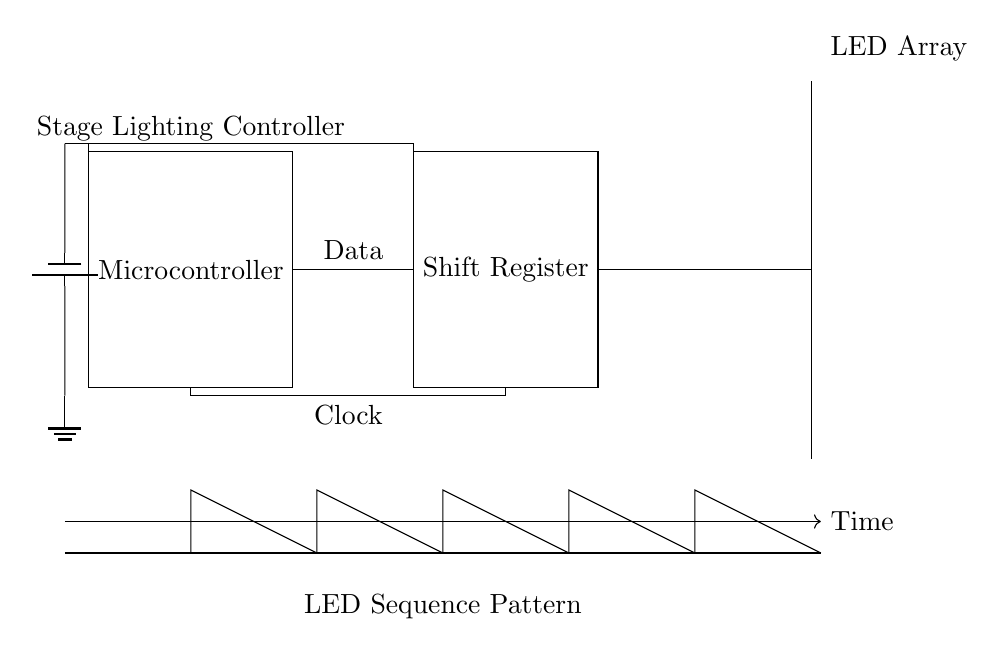What is the main component controlling the LED sequencing? The main component is the Microcontroller, as it interfaces with the shift register to send data and control the LED pattern.
Answer: Microcontroller How many LEDs are present in the circuit? The circuit includes a total of seven LEDs, which are shown arranged in a vertical line on the right side of the diagram.
Answer: Seven What type of register is used in this circuit? The circuit utilizes a Shift Register, which is responsible for receiving the data from the Microcontroller and controlling the LEDs accordingly.
Answer: Shift Register What is the primary function of the clock signal in this circuit? The Clock signal is used to synchronize the data transfer from the Microcontroller to the Shift Register, ensuring that the data is processed in a timely manner.
Answer: Synchronization What is the power source for this circuit? The power source is a battery, depicted at the left side of the circuit diagram, which supplies the necessary voltage to the Microcontroller and Shift Register.
Answer: Battery Why is there a timing diagram included in the circuit? The timing diagram illustrates the pattern of the LED sequence over time, helping to understand how the LEDs are activated in relation to clock pulses and data signals.
Answer: To visualize LED sequencing 